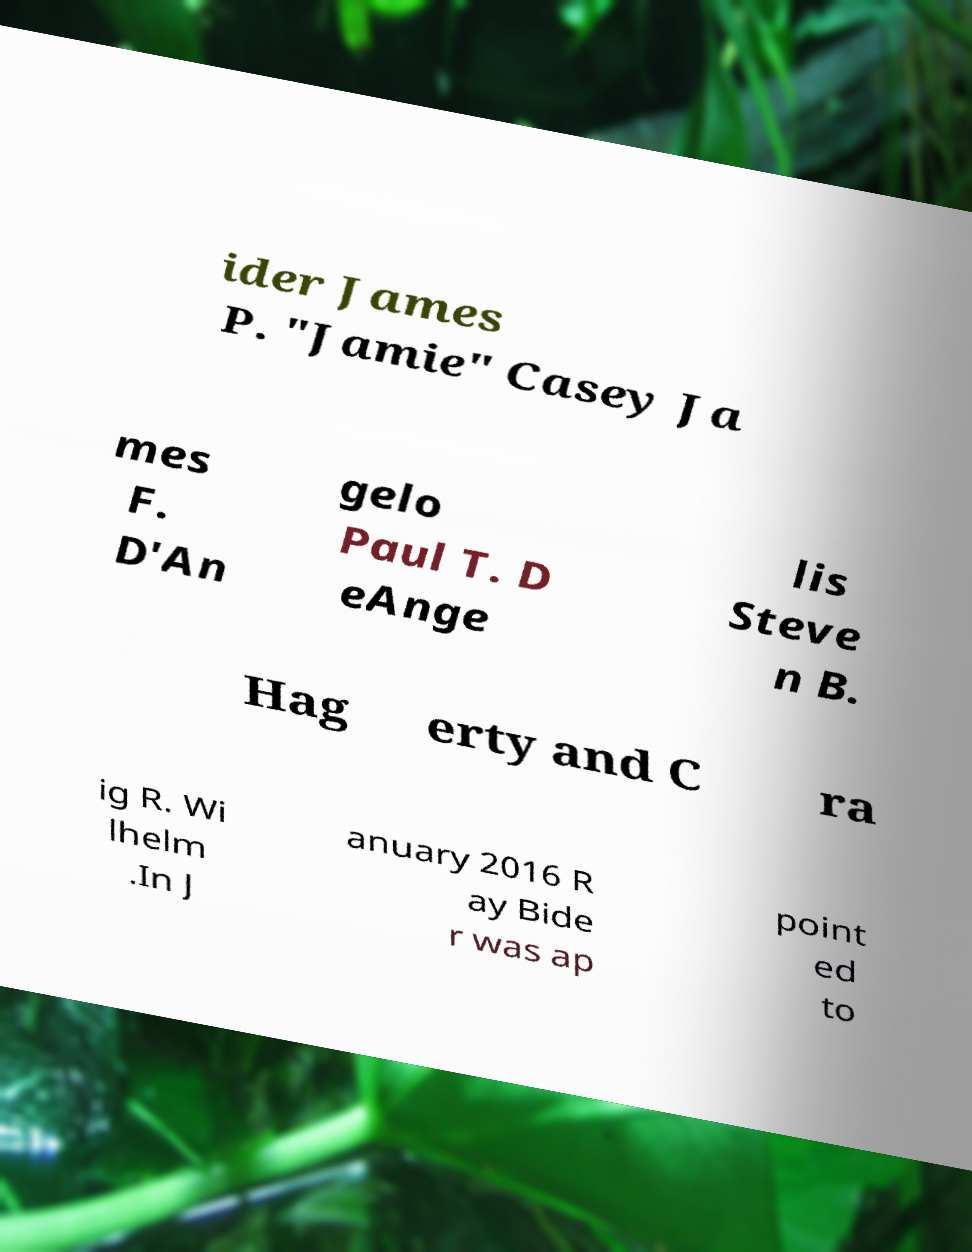What messages or text are displayed in this image? I need them in a readable, typed format. ider James P. "Jamie" Casey Ja mes F. D'An gelo Paul T. D eAnge lis Steve n B. Hag erty and C ra ig R. Wi lhelm .In J anuary 2016 R ay Bide r was ap point ed to 